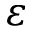Convert formula to latex. <formula><loc_0><loc_0><loc_500><loc_500>\varepsilon</formula> 